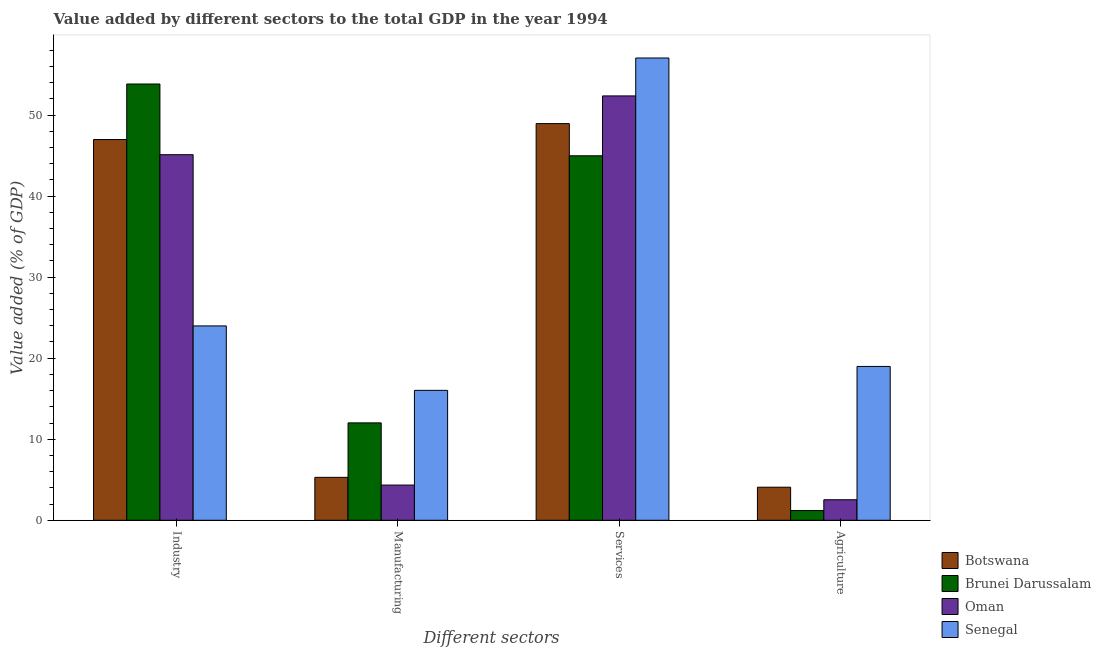How many groups of bars are there?
Provide a short and direct response. 4. Are the number of bars on each tick of the X-axis equal?
Keep it short and to the point. Yes. What is the label of the 3rd group of bars from the left?
Provide a short and direct response. Services. What is the value added by services sector in Oman?
Provide a succinct answer. 52.36. Across all countries, what is the maximum value added by services sector?
Provide a short and direct response. 57.04. Across all countries, what is the minimum value added by manufacturing sector?
Make the answer very short. 4.34. In which country was the value added by manufacturing sector maximum?
Your answer should be very brief. Senegal. In which country was the value added by industrial sector minimum?
Your answer should be very brief. Senegal. What is the total value added by services sector in the graph?
Your response must be concise. 203.32. What is the difference between the value added by industrial sector in Botswana and that in Brunei Darussalam?
Your response must be concise. -6.85. What is the difference between the value added by agricultural sector in Botswana and the value added by services sector in Oman?
Your response must be concise. -48.28. What is the average value added by manufacturing sector per country?
Provide a short and direct response. 9.42. What is the difference between the value added by services sector and value added by industrial sector in Botswana?
Your answer should be compact. 1.96. What is the ratio of the value added by manufacturing sector in Brunei Darussalam to that in Senegal?
Give a very brief answer. 0.75. Is the value added by agricultural sector in Botswana less than that in Senegal?
Provide a short and direct response. Yes. Is the difference between the value added by manufacturing sector in Brunei Darussalam and Senegal greater than the difference between the value added by industrial sector in Brunei Darussalam and Senegal?
Your response must be concise. No. What is the difference between the highest and the second highest value added by services sector?
Your answer should be very brief. 4.68. What is the difference between the highest and the lowest value added by services sector?
Your response must be concise. 12.07. What does the 4th bar from the left in Services represents?
Offer a very short reply. Senegal. What does the 4th bar from the right in Manufacturing represents?
Your response must be concise. Botswana. How many bars are there?
Make the answer very short. 16. Are all the bars in the graph horizontal?
Keep it short and to the point. No. Are the values on the major ticks of Y-axis written in scientific E-notation?
Provide a succinct answer. No. How many legend labels are there?
Ensure brevity in your answer.  4. What is the title of the graph?
Provide a short and direct response. Value added by different sectors to the total GDP in the year 1994. What is the label or title of the X-axis?
Give a very brief answer. Different sectors. What is the label or title of the Y-axis?
Provide a succinct answer. Value added (% of GDP). What is the Value added (% of GDP) in Botswana in Industry?
Make the answer very short. 46.98. What is the Value added (% of GDP) of Brunei Darussalam in Industry?
Ensure brevity in your answer.  53.83. What is the Value added (% of GDP) in Oman in Industry?
Ensure brevity in your answer.  45.11. What is the Value added (% of GDP) in Senegal in Industry?
Ensure brevity in your answer.  23.98. What is the Value added (% of GDP) of Botswana in Manufacturing?
Offer a terse response. 5.29. What is the Value added (% of GDP) in Brunei Darussalam in Manufacturing?
Make the answer very short. 12.02. What is the Value added (% of GDP) of Oman in Manufacturing?
Offer a terse response. 4.34. What is the Value added (% of GDP) in Senegal in Manufacturing?
Provide a succinct answer. 16.03. What is the Value added (% of GDP) in Botswana in Services?
Offer a very short reply. 48.94. What is the Value added (% of GDP) of Brunei Darussalam in Services?
Your answer should be compact. 44.97. What is the Value added (% of GDP) of Oman in Services?
Offer a terse response. 52.36. What is the Value added (% of GDP) of Senegal in Services?
Make the answer very short. 57.04. What is the Value added (% of GDP) in Botswana in Agriculture?
Your answer should be very brief. 4.08. What is the Value added (% of GDP) of Brunei Darussalam in Agriculture?
Your answer should be very brief. 1.2. What is the Value added (% of GDP) in Oman in Agriculture?
Offer a terse response. 2.53. What is the Value added (% of GDP) in Senegal in Agriculture?
Provide a succinct answer. 18.98. Across all Different sectors, what is the maximum Value added (% of GDP) of Botswana?
Offer a terse response. 48.94. Across all Different sectors, what is the maximum Value added (% of GDP) of Brunei Darussalam?
Your answer should be compact. 53.83. Across all Different sectors, what is the maximum Value added (% of GDP) in Oman?
Your response must be concise. 52.36. Across all Different sectors, what is the maximum Value added (% of GDP) in Senegal?
Keep it short and to the point. 57.04. Across all Different sectors, what is the minimum Value added (% of GDP) in Botswana?
Your answer should be compact. 4.08. Across all Different sectors, what is the minimum Value added (% of GDP) of Brunei Darussalam?
Give a very brief answer. 1.2. Across all Different sectors, what is the minimum Value added (% of GDP) of Oman?
Offer a very short reply. 2.53. Across all Different sectors, what is the minimum Value added (% of GDP) in Senegal?
Provide a short and direct response. 16.03. What is the total Value added (% of GDP) of Botswana in the graph?
Your answer should be very brief. 105.29. What is the total Value added (% of GDP) in Brunei Darussalam in the graph?
Keep it short and to the point. 112.02. What is the total Value added (% of GDP) in Oman in the graph?
Your answer should be very brief. 104.34. What is the total Value added (% of GDP) in Senegal in the graph?
Provide a succinct answer. 116.03. What is the difference between the Value added (% of GDP) in Botswana in Industry and that in Manufacturing?
Your answer should be compact. 41.68. What is the difference between the Value added (% of GDP) of Brunei Darussalam in Industry and that in Manufacturing?
Make the answer very short. 41.81. What is the difference between the Value added (% of GDP) of Oman in Industry and that in Manufacturing?
Provide a succinct answer. 40.76. What is the difference between the Value added (% of GDP) in Senegal in Industry and that in Manufacturing?
Keep it short and to the point. 7.95. What is the difference between the Value added (% of GDP) in Botswana in Industry and that in Services?
Offer a terse response. -1.97. What is the difference between the Value added (% of GDP) in Brunei Darussalam in Industry and that in Services?
Offer a very short reply. 8.86. What is the difference between the Value added (% of GDP) in Oman in Industry and that in Services?
Your answer should be compact. -7.25. What is the difference between the Value added (% of GDP) of Senegal in Industry and that in Services?
Ensure brevity in your answer.  -33.06. What is the difference between the Value added (% of GDP) of Botswana in Industry and that in Agriculture?
Provide a succinct answer. 42.9. What is the difference between the Value added (% of GDP) in Brunei Darussalam in Industry and that in Agriculture?
Provide a short and direct response. 52.63. What is the difference between the Value added (% of GDP) of Oman in Industry and that in Agriculture?
Ensure brevity in your answer.  42.57. What is the difference between the Value added (% of GDP) of Senegal in Industry and that in Agriculture?
Make the answer very short. 5. What is the difference between the Value added (% of GDP) of Botswana in Manufacturing and that in Services?
Your response must be concise. -43.65. What is the difference between the Value added (% of GDP) in Brunei Darussalam in Manufacturing and that in Services?
Ensure brevity in your answer.  -32.96. What is the difference between the Value added (% of GDP) of Oman in Manufacturing and that in Services?
Offer a terse response. -48.02. What is the difference between the Value added (% of GDP) in Senegal in Manufacturing and that in Services?
Your response must be concise. -41.01. What is the difference between the Value added (% of GDP) of Botswana in Manufacturing and that in Agriculture?
Keep it short and to the point. 1.22. What is the difference between the Value added (% of GDP) of Brunei Darussalam in Manufacturing and that in Agriculture?
Offer a terse response. 10.82. What is the difference between the Value added (% of GDP) in Oman in Manufacturing and that in Agriculture?
Give a very brief answer. 1.81. What is the difference between the Value added (% of GDP) of Senegal in Manufacturing and that in Agriculture?
Give a very brief answer. -2.95. What is the difference between the Value added (% of GDP) of Botswana in Services and that in Agriculture?
Ensure brevity in your answer.  44.86. What is the difference between the Value added (% of GDP) in Brunei Darussalam in Services and that in Agriculture?
Provide a short and direct response. 43.77. What is the difference between the Value added (% of GDP) in Oman in Services and that in Agriculture?
Provide a short and direct response. 49.83. What is the difference between the Value added (% of GDP) in Senegal in Services and that in Agriculture?
Keep it short and to the point. 38.06. What is the difference between the Value added (% of GDP) in Botswana in Industry and the Value added (% of GDP) in Brunei Darussalam in Manufacturing?
Your answer should be very brief. 34.96. What is the difference between the Value added (% of GDP) in Botswana in Industry and the Value added (% of GDP) in Oman in Manufacturing?
Provide a succinct answer. 42.64. What is the difference between the Value added (% of GDP) of Botswana in Industry and the Value added (% of GDP) of Senegal in Manufacturing?
Ensure brevity in your answer.  30.95. What is the difference between the Value added (% of GDP) in Brunei Darussalam in Industry and the Value added (% of GDP) in Oman in Manufacturing?
Your response must be concise. 49.49. What is the difference between the Value added (% of GDP) of Brunei Darussalam in Industry and the Value added (% of GDP) of Senegal in Manufacturing?
Provide a short and direct response. 37.8. What is the difference between the Value added (% of GDP) in Oman in Industry and the Value added (% of GDP) in Senegal in Manufacturing?
Provide a short and direct response. 29.08. What is the difference between the Value added (% of GDP) of Botswana in Industry and the Value added (% of GDP) of Brunei Darussalam in Services?
Provide a short and direct response. 2.01. What is the difference between the Value added (% of GDP) of Botswana in Industry and the Value added (% of GDP) of Oman in Services?
Your answer should be very brief. -5.38. What is the difference between the Value added (% of GDP) of Botswana in Industry and the Value added (% of GDP) of Senegal in Services?
Offer a very short reply. -10.06. What is the difference between the Value added (% of GDP) in Brunei Darussalam in Industry and the Value added (% of GDP) in Oman in Services?
Your response must be concise. 1.47. What is the difference between the Value added (% of GDP) in Brunei Darussalam in Industry and the Value added (% of GDP) in Senegal in Services?
Ensure brevity in your answer.  -3.21. What is the difference between the Value added (% of GDP) of Oman in Industry and the Value added (% of GDP) of Senegal in Services?
Your response must be concise. -11.93. What is the difference between the Value added (% of GDP) of Botswana in Industry and the Value added (% of GDP) of Brunei Darussalam in Agriculture?
Provide a short and direct response. 45.78. What is the difference between the Value added (% of GDP) in Botswana in Industry and the Value added (% of GDP) in Oman in Agriculture?
Ensure brevity in your answer.  44.45. What is the difference between the Value added (% of GDP) in Botswana in Industry and the Value added (% of GDP) in Senegal in Agriculture?
Your response must be concise. 28. What is the difference between the Value added (% of GDP) in Brunei Darussalam in Industry and the Value added (% of GDP) in Oman in Agriculture?
Keep it short and to the point. 51.3. What is the difference between the Value added (% of GDP) of Brunei Darussalam in Industry and the Value added (% of GDP) of Senegal in Agriculture?
Offer a terse response. 34.85. What is the difference between the Value added (% of GDP) of Oman in Industry and the Value added (% of GDP) of Senegal in Agriculture?
Provide a succinct answer. 26.13. What is the difference between the Value added (% of GDP) of Botswana in Manufacturing and the Value added (% of GDP) of Brunei Darussalam in Services?
Offer a very short reply. -39.68. What is the difference between the Value added (% of GDP) of Botswana in Manufacturing and the Value added (% of GDP) of Oman in Services?
Ensure brevity in your answer.  -47.07. What is the difference between the Value added (% of GDP) of Botswana in Manufacturing and the Value added (% of GDP) of Senegal in Services?
Ensure brevity in your answer.  -51.74. What is the difference between the Value added (% of GDP) of Brunei Darussalam in Manufacturing and the Value added (% of GDP) of Oman in Services?
Make the answer very short. -40.34. What is the difference between the Value added (% of GDP) of Brunei Darussalam in Manufacturing and the Value added (% of GDP) of Senegal in Services?
Provide a succinct answer. -45.02. What is the difference between the Value added (% of GDP) of Oman in Manufacturing and the Value added (% of GDP) of Senegal in Services?
Provide a short and direct response. -52.7. What is the difference between the Value added (% of GDP) in Botswana in Manufacturing and the Value added (% of GDP) in Brunei Darussalam in Agriculture?
Ensure brevity in your answer.  4.1. What is the difference between the Value added (% of GDP) in Botswana in Manufacturing and the Value added (% of GDP) in Oman in Agriculture?
Make the answer very short. 2.76. What is the difference between the Value added (% of GDP) of Botswana in Manufacturing and the Value added (% of GDP) of Senegal in Agriculture?
Offer a very short reply. -13.69. What is the difference between the Value added (% of GDP) in Brunei Darussalam in Manufacturing and the Value added (% of GDP) in Oman in Agriculture?
Your answer should be compact. 9.48. What is the difference between the Value added (% of GDP) in Brunei Darussalam in Manufacturing and the Value added (% of GDP) in Senegal in Agriculture?
Make the answer very short. -6.96. What is the difference between the Value added (% of GDP) in Oman in Manufacturing and the Value added (% of GDP) in Senegal in Agriculture?
Provide a short and direct response. -14.64. What is the difference between the Value added (% of GDP) of Botswana in Services and the Value added (% of GDP) of Brunei Darussalam in Agriculture?
Provide a succinct answer. 47.74. What is the difference between the Value added (% of GDP) in Botswana in Services and the Value added (% of GDP) in Oman in Agriculture?
Offer a terse response. 46.41. What is the difference between the Value added (% of GDP) of Botswana in Services and the Value added (% of GDP) of Senegal in Agriculture?
Provide a short and direct response. 29.96. What is the difference between the Value added (% of GDP) in Brunei Darussalam in Services and the Value added (% of GDP) in Oman in Agriculture?
Keep it short and to the point. 42.44. What is the difference between the Value added (% of GDP) of Brunei Darussalam in Services and the Value added (% of GDP) of Senegal in Agriculture?
Offer a very short reply. 25.99. What is the difference between the Value added (% of GDP) in Oman in Services and the Value added (% of GDP) in Senegal in Agriculture?
Your answer should be very brief. 33.38. What is the average Value added (% of GDP) in Botswana per Different sectors?
Offer a terse response. 26.32. What is the average Value added (% of GDP) in Brunei Darussalam per Different sectors?
Provide a succinct answer. 28. What is the average Value added (% of GDP) of Oman per Different sectors?
Make the answer very short. 26.09. What is the average Value added (% of GDP) in Senegal per Different sectors?
Make the answer very short. 29.01. What is the difference between the Value added (% of GDP) in Botswana and Value added (% of GDP) in Brunei Darussalam in Industry?
Offer a terse response. -6.85. What is the difference between the Value added (% of GDP) of Botswana and Value added (% of GDP) of Oman in Industry?
Your response must be concise. 1.87. What is the difference between the Value added (% of GDP) in Botswana and Value added (% of GDP) in Senegal in Industry?
Your response must be concise. 23. What is the difference between the Value added (% of GDP) of Brunei Darussalam and Value added (% of GDP) of Oman in Industry?
Give a very brief answer. 8.72. What is the difference between the Value added (% of GDP) in Brunei Darussalam and Value added (% of GDP) in Senegal in Industry?
Your response must be concise. 29.85. What is the difference between the Value added (% of GDP) in Oman and Value added (% of GDP) in Senegal in Industry?
Provide a succinct answer. 21.13. What is the difference between the Value added (% of GDP) of Botswana and Value added (% of GDP) of Brunei Darussalam in Manufacturing?
Keep it short and to the point. -6.72. What is the difference between the Value added (% of GDP) of Botswana and Value added (% of GDP) of Oman in Manufacturing?
Your answer should be compact. 0.95. What is the difference between the Value added (% of GDP) in Botswana and Value added (% of GDP) in Senegal in Manufacturing?
Your answer should be very brief. -10.74. What is the difference between the Value added (% of GDP) of Brunei Darussalam and Value added (% of GDP) of Oman in Manufacturing?
Your answer should be very brief. 7.67. What is the difference between the Value added (% of GDP) of Brunei Darussalam and Value added (% of GDP) of Senegal in Manufacturing?
Your answer should be very brief. -4.01. What is the difference between the Value added (% of GDP) of Oman and Value added (% of GDP) of Senegal in Manufacturing?
Provide a succinct answer. -11.69. What is the difference between the Value added (% of GDP) in Botswana and Value added (% of GDP) in Brunei Darussalam in Services?
Offer a very short reply. 3.97. What is the difference between the Value added (% of GDP) of Botswana and Value added (% of GDP) of Oman in Services?
Offer a terse response. -3.42. What is the difference between the Value added (% of GDP) of Botswana and Value added (% of GDP) of Senegal in Services?
Offer a terse response. -8.1. What is the difference between the Value added (% of GDP) in Brunei Darussalam and Value added (% of GDP) in Oman in Services?
Keep it short and to the point. -7.39. What is the difference between the Value added (% of GDP) of Brunei Darussalam and Value added (% of GDP) of Senegal in Services?
Keep it short and to the point. -12.07. What is the difference between the Value added (% of GDP) of Oman and Value added (% of GDP) of Senegal in Services?
Make the answer very short. -4.68. What is the difference between the Value added (% of GDP) of Botswana and Value added (% of GDP) of Brunei Darussalam in Agriculture?
Your answer should be very brief. 2.88. What is the difference between the Value added (% of GDP) in Botswana and Value added (% of GDP) in Oman in Agriculture?
Your response must be concise. 1.55. What is the difference between the Value added (% of GDP) in Botswana and Value added (% of GDP) in Senegal in Agriculture?
Ensure brevity in your answer.  -14.9. What is the difference between the Value added (% of GDP) of Brunei Darussalam and Value added (% of GDP) of Oman in Agriculture?
Keep it short and to the point. -1.33. What is the difference between the Value added (% of GDP) in Brunei Darussalam and Value added (% of GDP) in Senegal in Agriculture?
Ensure brevity in your answer.  -17.78. What is the difference between the Value added (% of GDP) in Oman and Value added (% of GDP) in Senegal in Agriculture?
Make the answer very short. -16.45. What is the ratio of the Value added (% of GDP) of Botswana in Industry to that in Manufacturing?
Your answer should be compact. 8.87. What is the ratio of the Value added (% of GDP) in Brunei Darussalam in Industry to that in Manufacturing?
Your response must be concise. 4.48. What is the ratio of the Value added (% of GDP) of Oman in Industry to that in Manufacturing?
Offer a terse response. 10.39. What is the ratio of the Value added (% of GDP) of Senegal in Industry to that in Manufacturing?
Offer a terse response. 1.5. What is the ratio of the Value added (% of GDP) in Botswana in Industry to that in Services?
Keep it short and to the point. 0.96. What is the ratio of the Value added (% of GDP) of Brunei Darussalam in Industry to that in Services?
Offer a terse response. 1.2. What is the ratio of the Value added (% of GDP) in Oman in Industry to that in Services?
Provide a succinct answer. 0.86. What is the ratio of the Value added (% of GDP) of Senegal in Industry to that in Services?
Your response must be concise. 0.42. What is the ratio of the Value added (% of GDP) in Botswana in Industry to that in Agriculture?
Provide a succinct answer. 11.52. What is the ratio of the Value added (% of GDP) of Brunei Darussalam in Industry to that in Agriculture?
Make the answer very short. 44.91. What is the ratio of the Value added (% of GDP) of Oman in Industry to that in Agriculture?
Your response must be concise. 17.81. What is the ratio of the Value added (% of GDP) in Senegal in Industry to that in Agriculture?
Offer a terse response. 1.26. What is the ratio of the Value added (% of GDP) of Botswana in Manufacturing to that in Services?
Your response must be concise. 0.11. What is the ratio of the Value added (% of GDP) in Brunei Darussalam in Manufacturing to that in Services?
Provide a succinct answer. 0.27. What is the ratio of the Value added (% of GDP) of Oman in Manufacturing to that in Services?
Your response must be concise. 0.08. What is the ratio of the Value added (% of GDP) of Senegal in Manufacturing to that in Services?
Your answer should be compact. 0.28. What is the ratio of the Value added (% of GDP) in Botswana in Manufacturing to that in Agriculture?
Provide a short and direct response. 1.3. What is the ratio of the Value added (% of GDP) in Brunei Darussalam in Manufacturing to that in Agriculture?
Your response must be concise. 10.02. What is the ratio of the Value added (% of GDP) in Oman in Manufacturing to that in Agriculture?
Offer a terse response. 1.71. What is the ratio of the Value added (% of GDP) in Senegal in Manufacturing to that in Agriculture?
Keep it short and to the point. 0.84. What is the ratio of the Value added (% of GDP) of Botswana in Services to that in Agriculture?
Make the answer very short. 12. What is the ratio of the Value added (% of GDP) in Brunei Darussalam in Services to that in Agriculture?
Make the answer very short. 37.52. What is the ratio of the Value added (% of GDP) of Oman in Services to that in Agriculture?
Your answer should be compact. 20.67. What is the ratio of the Value added (% of GDP) of Senegal in Services to that in Agriculture?
Offer a very short reply. 3.01. What is the difference between the highest and the second highest Value added (% of GDP) of Botswana?
Offer a very short reply. 1.97. What is the difference between the highest and the second highest Value added (% of GDP) of Brunei Darussalam?
Give a very brief answer. 8.86. What is the difference between the highest and the second highest Value added (% of GDP) of Oman?
Your response must be concise. 7.25. What is the difference between the highest and the second highest Value added (% of GDP) in Senegal?
Your answer should be compact. 33.06. What is the difference between the highest and the lowest Value added (% of GDP) in Botswana?
Give a very brief answer. 44.86. What is the difference between the highest and the lowest Value added (% of GDP) of Brunei Darussalam?
Your answer should be compact. 52.63. What is the difference between the highest and the lowest Value added (% of GDP) of Oman?
Make the answer very short. 49.83. What is the difference between the highest and the lowest Value added (% of GDP) of Senegal?
Give a very brief answer. 41.01. 